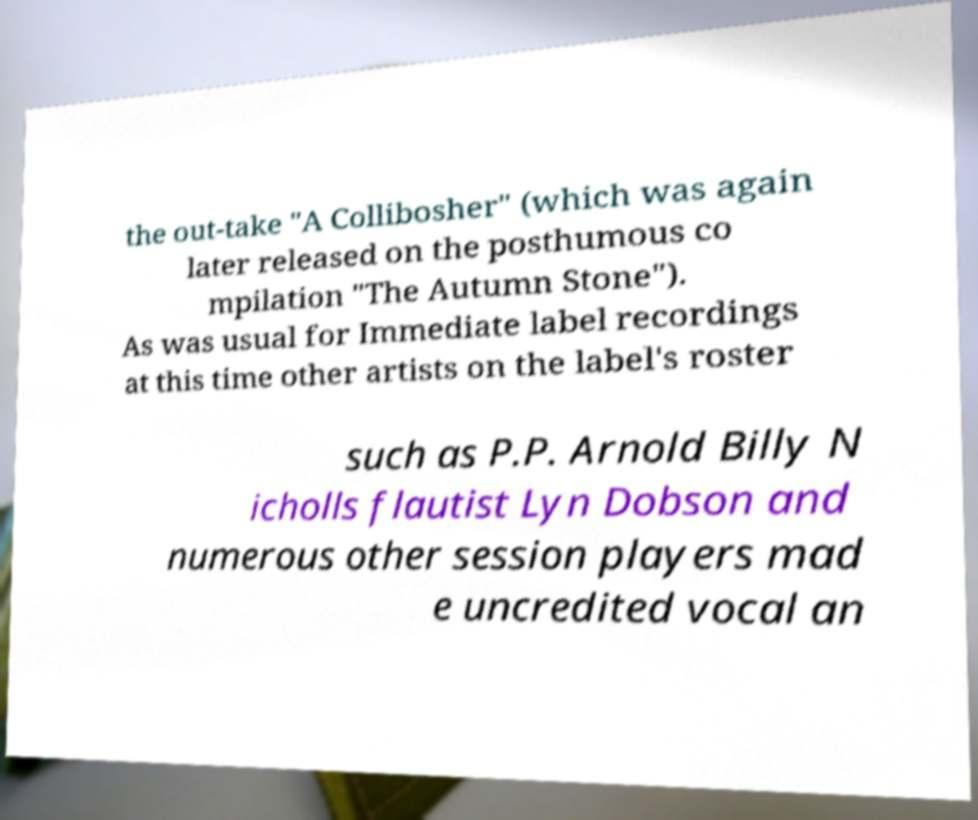Could you assist in decoding the text presented in this image and type it out clearly? the out-take "A Collibosher" (which was again later released on the posthumous co mpilation "The Autumn Stone"). As was usual for Immediate label recordings at this time other artists on the label's roster such as P.P. Arnold Billy N icholls flautist Lyn Dobson and numerous other session players mad e uncredited vocal an 